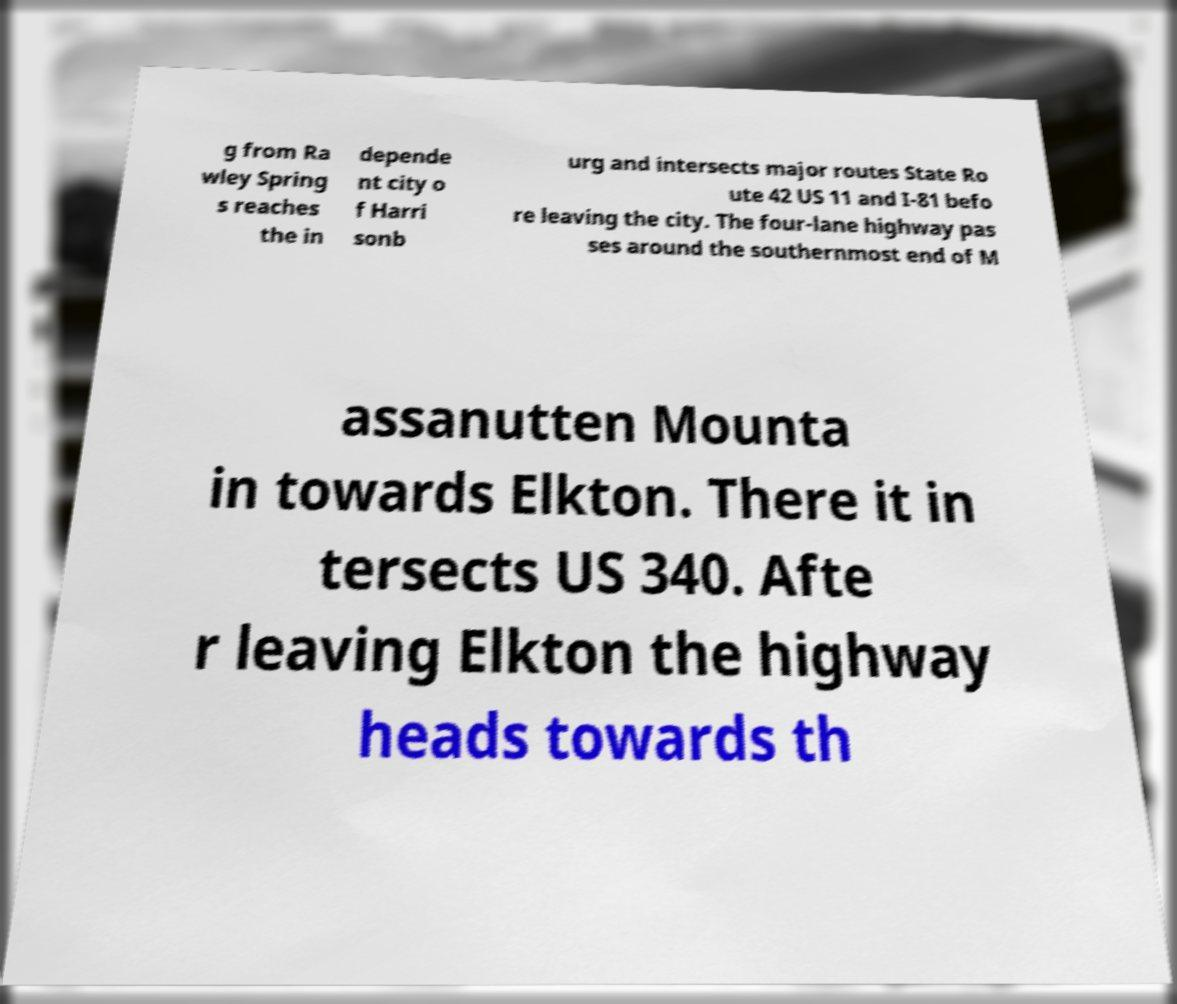Could you extract and type out the text from this image? g from Ra wley Spring s reaches the in depende nt city o f Harri sonb urg and intersects major routes State Ro ute 42 US 11 and I-81 befo re leaving the city. The four-lane highway pas ses around the southernmost end of M assanutten Mounta in towards Elkton. There it in tersects US 340. Afte r leaving Elkton the highway heads towards th 